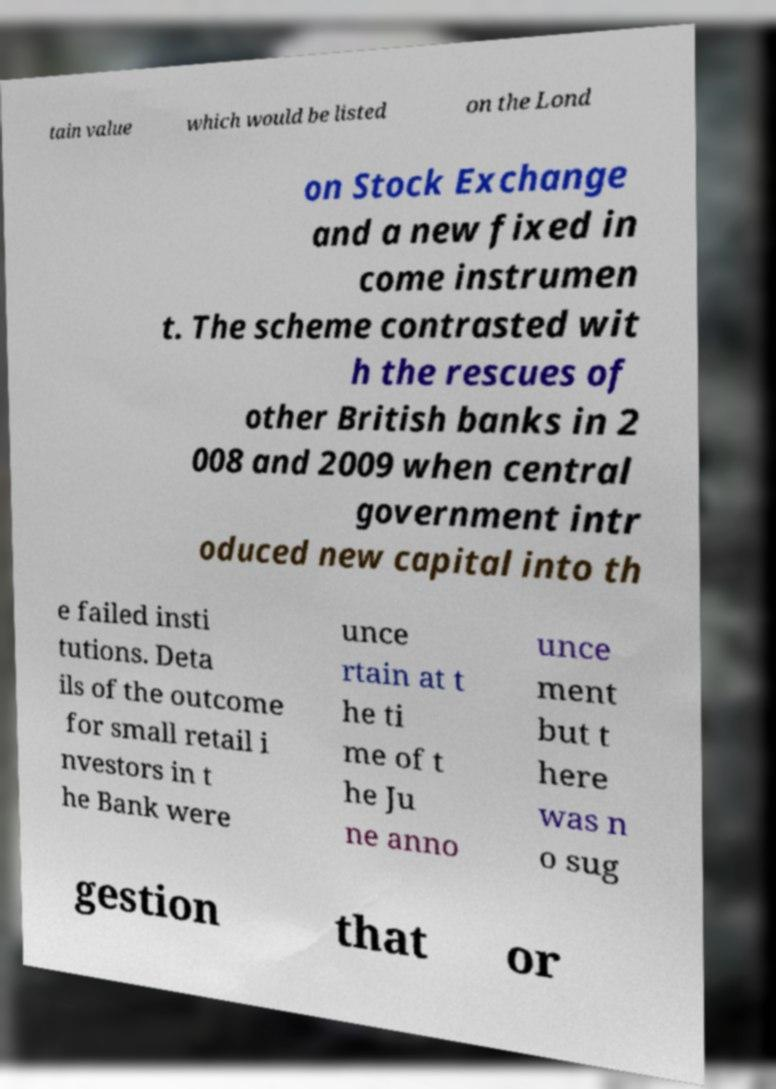There's text embedded in this image that I need extracted. Can you transcribe it verbatim? tain value which would be listed on the Lond on Stock Exchange and a new fixed in come instrumen t. The scheme contrasted wit h the rescues of other British banks in 2 008 and 2009 when central government intr oduced new capital into th e failed insti tutions. Deta ils of the outcome for small retail i nvestors in t he Bank were unce rtain at t he ti me of t he Ju ne anno unce ment but t here was n o sug gestion that or 